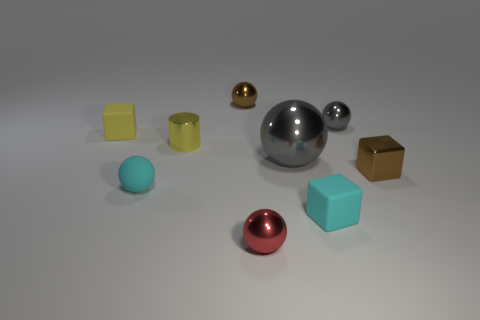What could the arrangement of these objects signify? The arrangement appears deliberate, creating a sense of balance and variety. The placement of objects with different shapes, sizes, and colors might suggest a study in diversity or a representation of an abstract composition. It could also be indicative of a visual demonstration for educational purposes, showing how light interacts with different surfaces, which would be useful in teaching concepts of physics or photography. 